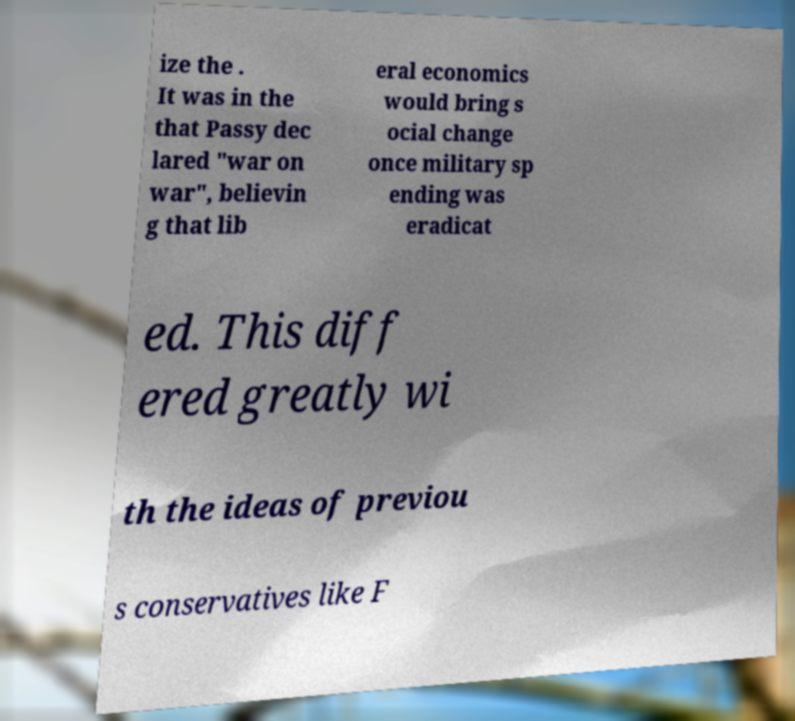Can you accurately transcribe the text from the provided image for me? ize the . It was in the that Passy dec lared "war on war", believin g that lib eral economics would bring s ocial change once military sp ending was eradicat ed. This diff ered greatly wi th the ideas of previou s conservatives like F 